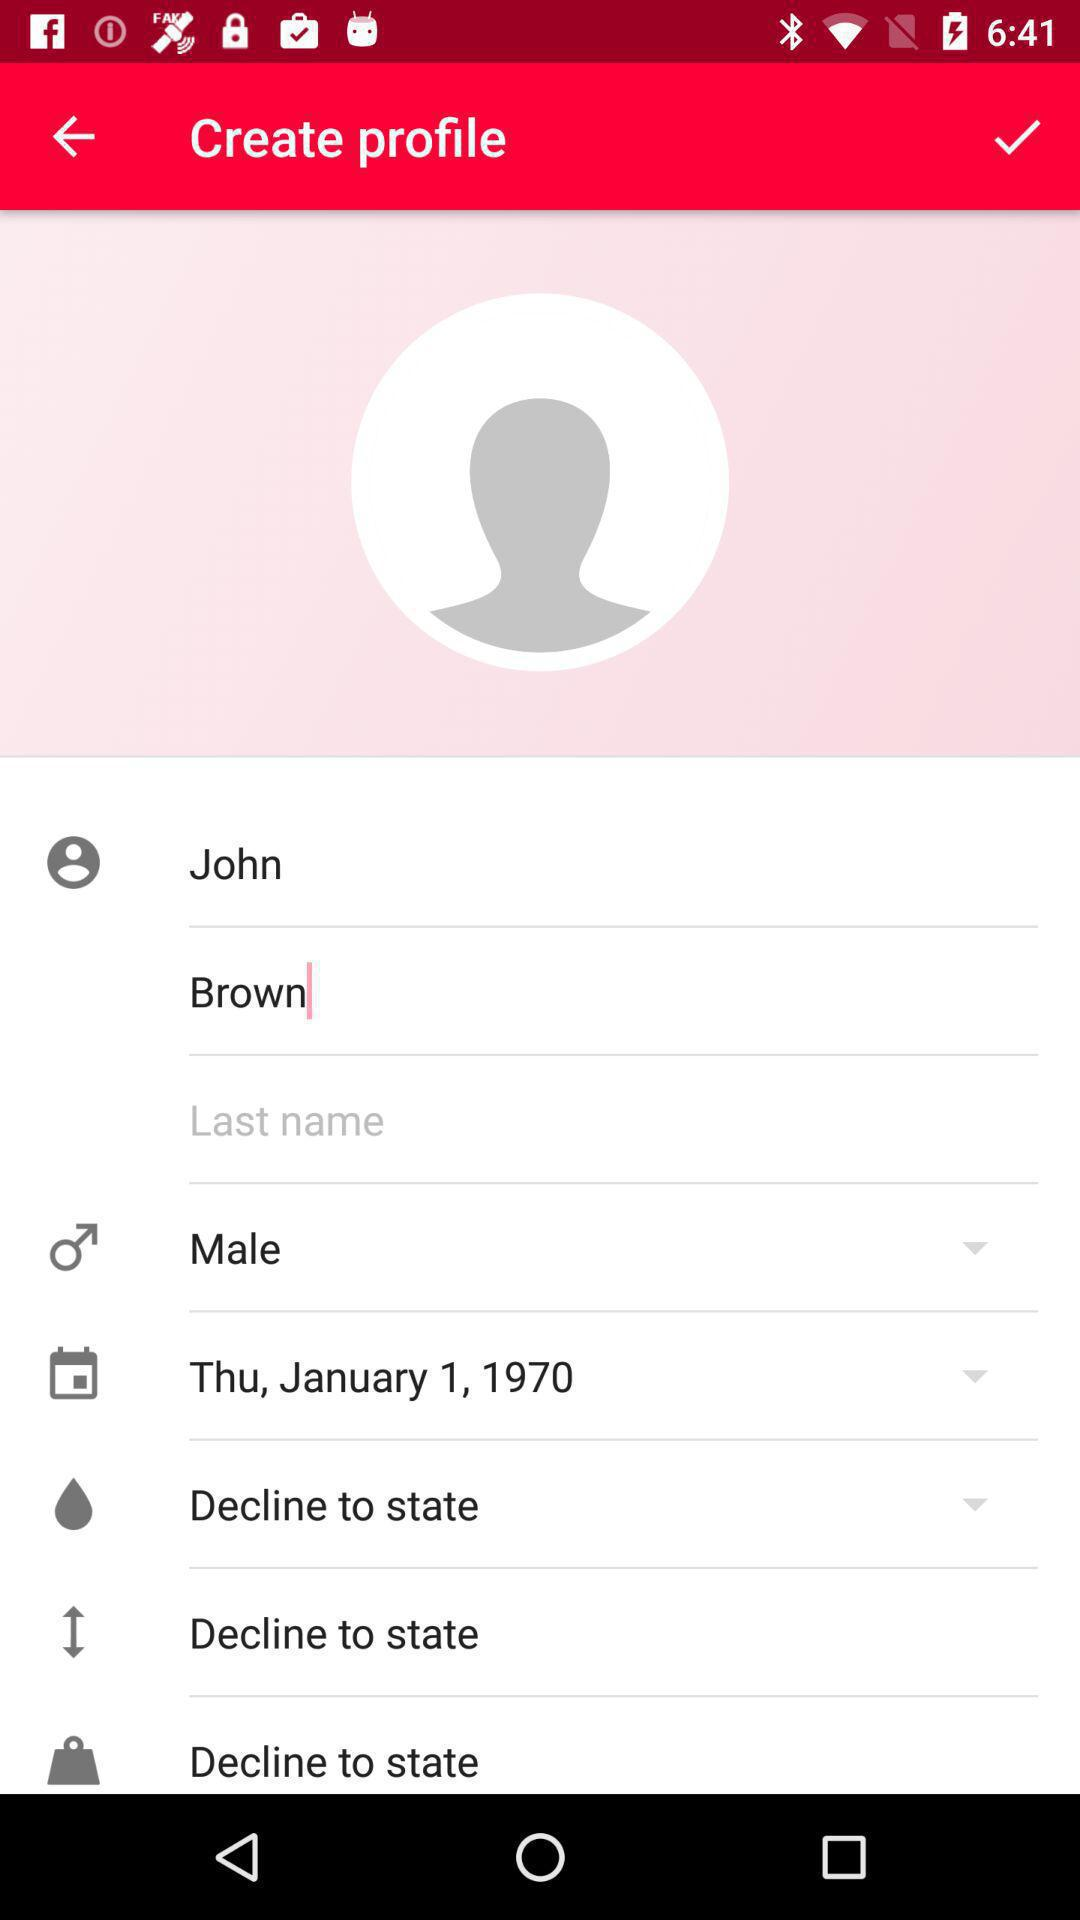What is the date of birth of the user? The date of birth of the user is Thursday, January 1, 1970. 